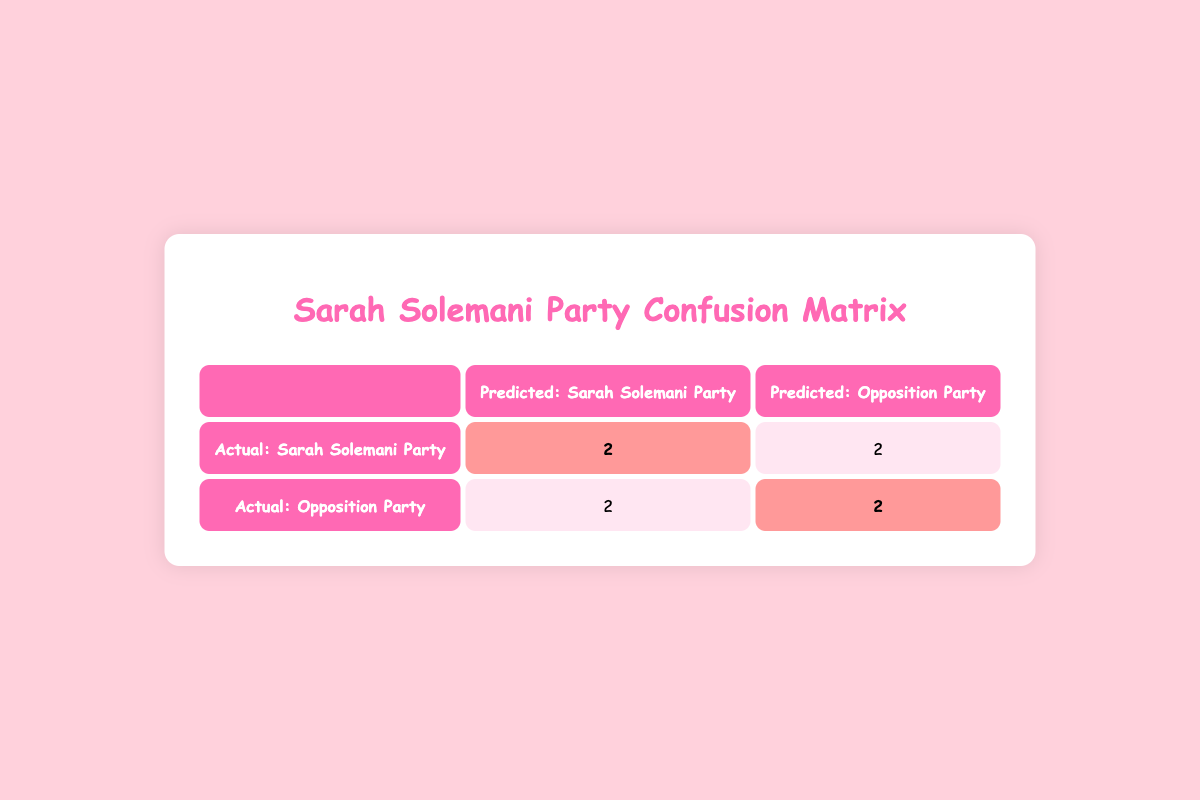What is the total number of voters who predicted they would vote for the Sarah Solemani Party? In the table, we can see under the "Predicted: Sarah Solemani Party" column that there are 2 voters who actually voted for the Sarah Solemani Party (highlighted) and 2 voters who predicted they would vote for the opposition party. Adding these values gives a total of 2 + 2 = 4 voters predicted to support the Sarah Solemani Party.
Answer: 4 How many voters actually voted for the Opposition Party? Referring to the "Actual: Opposition Party" row, we see that there are 2 voters who predicted they would vote for the Sarah Solemani Party and 2 voters who predicted they would vote for the Opposition Party. Therefore, the total number of voters who actually voted for the Opposition Party is 2 (highlighted).
Answer: 2 Is the number of voters who predicted to vote for the Opposition Party equal to the number of actual votes for that party? In the "Predicted: Opposition Party" column, there are 2 voters who actually voted for this party, and the corresponding cell in the row for "Actual: Opposition Party" also shows a count of 2. Thus, the number of predicted votes for the Opposition Party is equal to the actual votes.
Answer: Yes What is the proportion of correct predictions for the Sarah Solemani Party? The correct predictions for the Sarah Solemani Party are the 2 highlighted cells in the "Actual: Sarah Solemani Party" row. The total number of predictions made for the Sarah Solemani Party is 4 (2 correct + 2 incorrect). The proportion of correct predictions is calculated as 2/4 = 0.5, which means 50% of predictions were correct for this party.
Answer: 50% If a voter predicted they would vote for the Sarah Solemani Party, what is the likelihood they actually did so? Out of the 4 voters who predicted they would vote for the Sarah Solemani Party, 2 of them actually did vote for that party (highlighted cells). Therefore, the likelihood can be computed as 2/4 = 0.5 or 50%.
Answer: 50% 